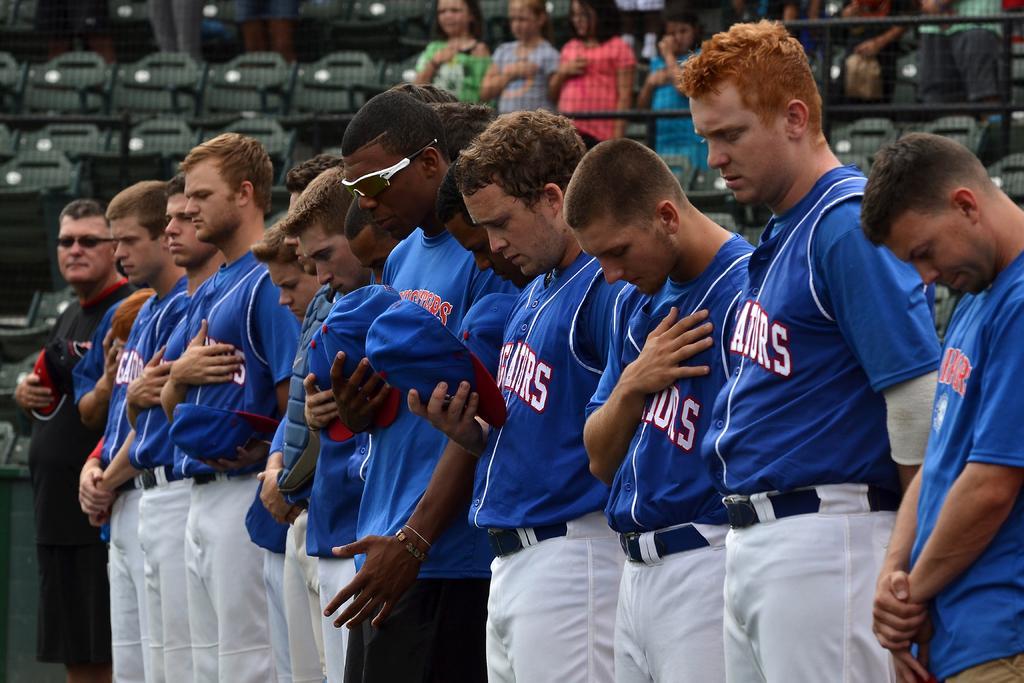How would you summarize this image in a sentence or two? In this image we can see group of men standing on the ground. In the background we can see fencing, persons and chairs. 